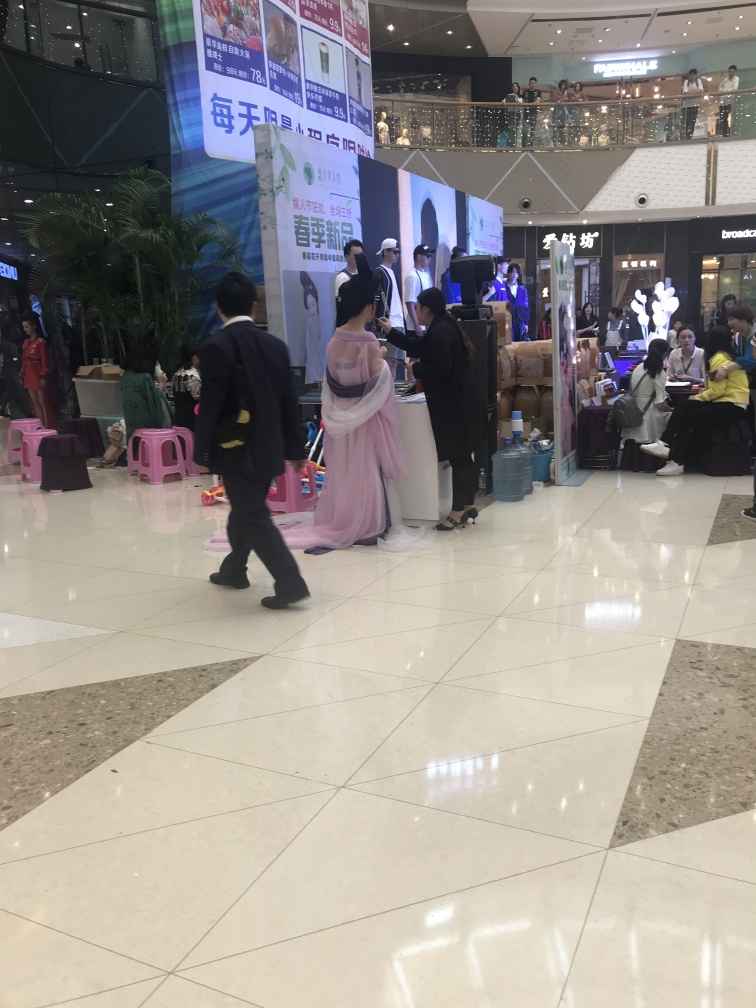What is the overall clarity of the image? The image's overall clarity is high with sharply captured details, such as the attire of individuals and the promotional banners; however, the image is slightly tilted which may affect the perception of clarity. 